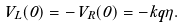<formula> <loc_0><loc_0><loc_500><loc_500>V _ { L } ( 0 ) = - V _ { R } ( 0 ) = - k q \eta .</formula> 